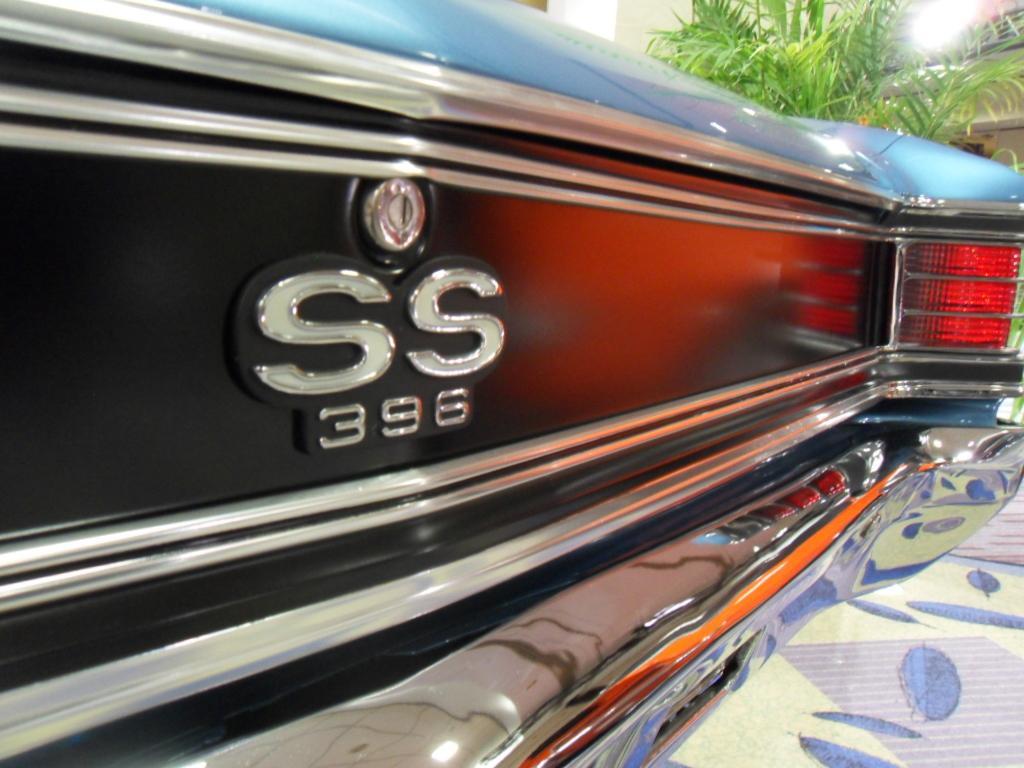Describe this image in one or two sentences. This is the car with tail light. This is the logo, which is attached to the car. I think this is a plant with leaves. 